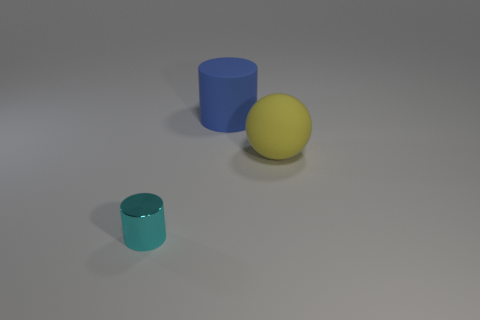What could be the texture of the objects? The objects appear to have a non-reflective, matte texture that indicates they might feel smooth to the touch, without any gloss or sheen. Do they seem to reflect any light? While they are matte and do not have a reflective surface, the objects subtly reflect some of the environmental light, creating soft shadows and highlights which give them a three-dimensional appearance. 